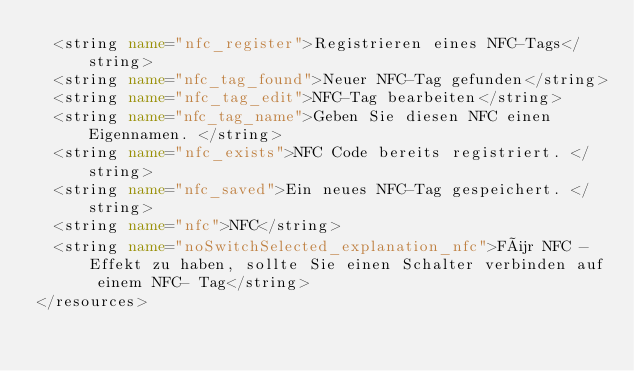<code> <loc_0><loc_0><loc_500><loc_500><_XML_>  <string name="nfc_register">Registrieren eines NFC-Tags</string>
  <string name="nfc_tag_found">Neuer NFC-Tag gefunden</string>
  <string name="nfc_tag_edit">NFC-Tag bearbeiten</string>
  <string name="nfc_tag_name">Geben Sie diesen NFC einen Eigennamen. </string>
  <string name="nfc_exists">NFC Code bereits registriert. </string>
  <string name="nfc_saved">Ein neues NFC-Tag gespeichert. </string>
  <string name="nfc">NFC</string>
  <string name="noSwitchSelected_explanation_nfc">Für NFC -Effekt zu haben, sollte Sie einen Schalter verbinden auf einem NFC- Tag</string>
</resources>
</code> 